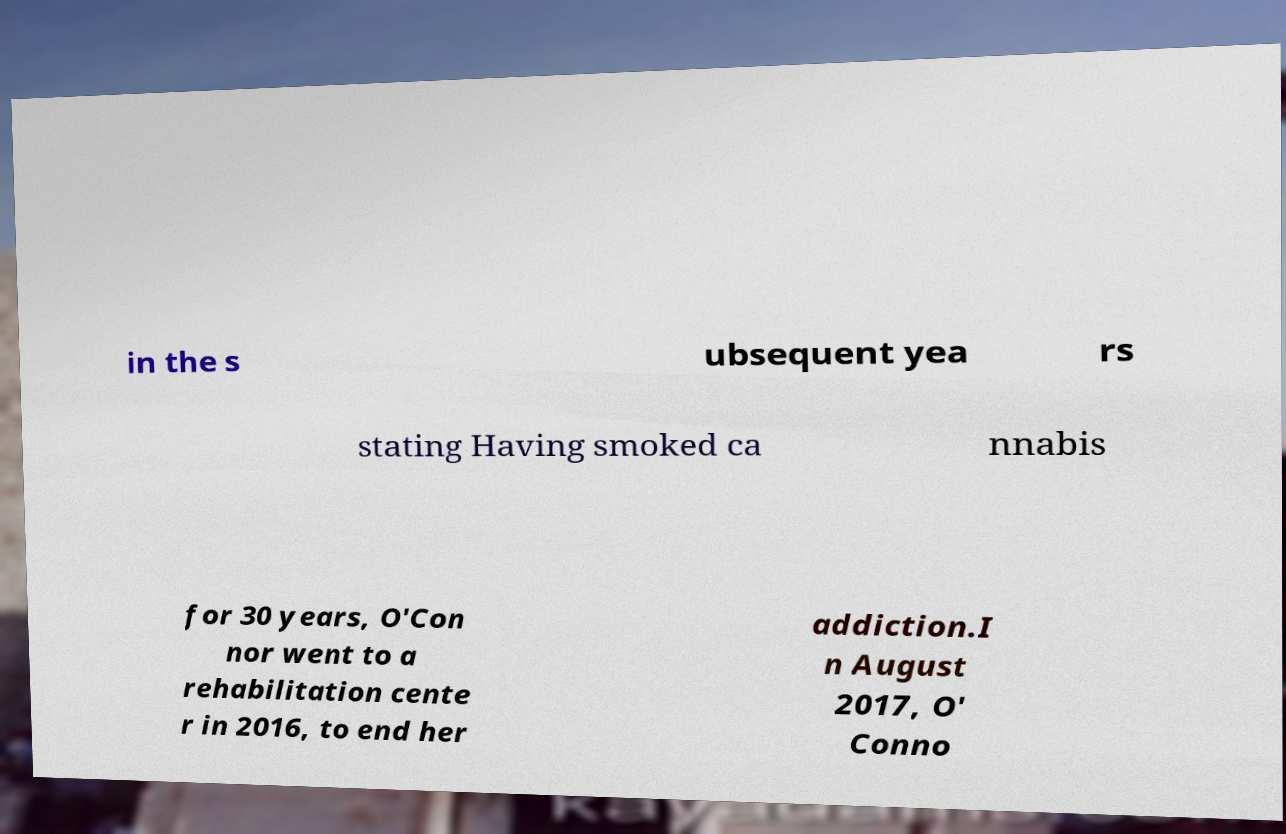Could you extract and type out the text from this image? in the s ubsequent yea rs stating Having smoked ca nnabis for 30 years, O'Con nor went to a rehabilitation cente r in 2016, to end her addiction.I n August 2017, O' Conno 